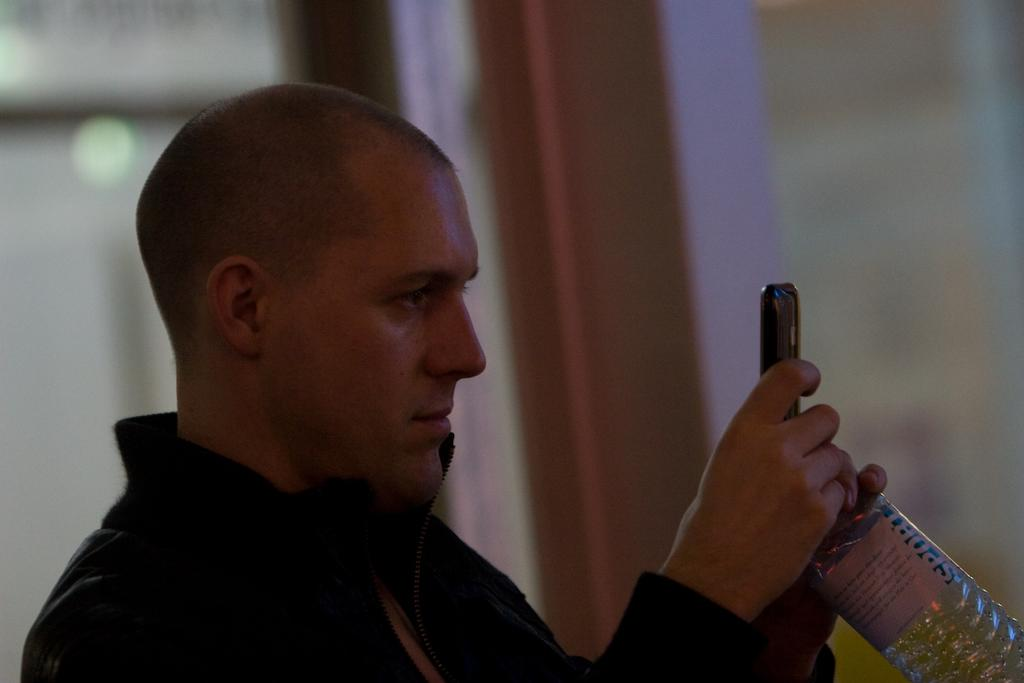Where was the image taken? The image was taken indoors. Who is present in the image? There is a man in the image. What is the man wearing? The man is wearing a black jacket. What objects is the man holding in the image? The man is holding a bottle and a mobile. Are there any pigs or bears visible in the image? No, there are no pigs or bears present in the image. Is there a recess area in the image? The image does not show a recess area; it is focused on the man and the objects he is holding. 